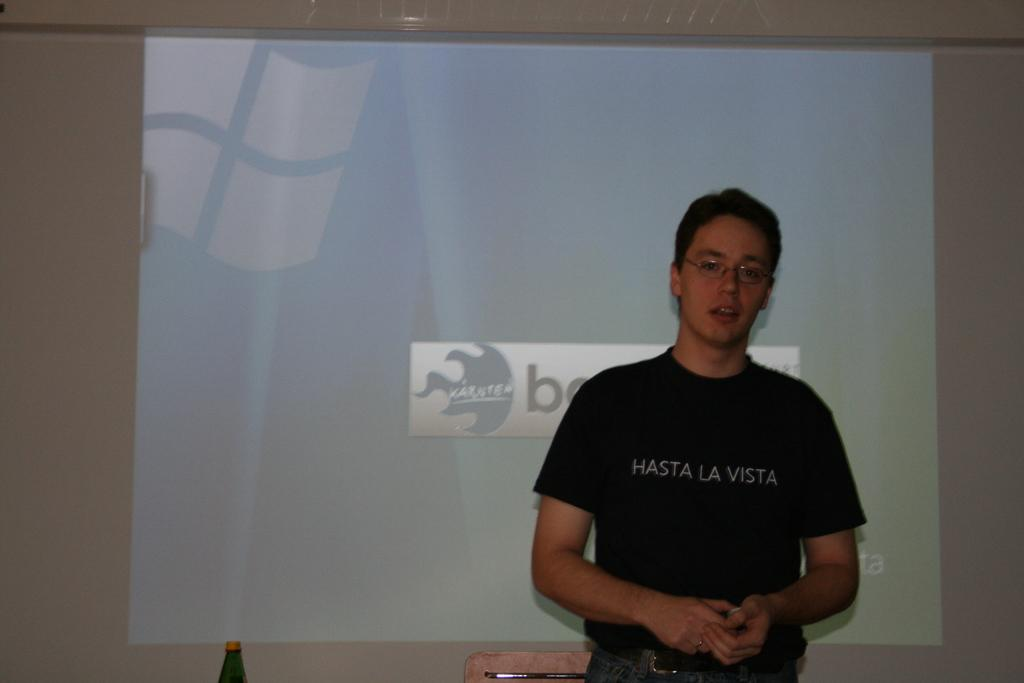What is the main subject of the image? There is a man standing in the image. Can you describe the man's appearance? The man is wearing spectacles. What can be seen in the background of the image? There is a projector wall in the background. What furniture is present in the image? There is a table in the image. What object is on the table? There is a bottle on the table. What type of disease is the man suffering from in the image? There is no indication in the image that the man is suffering from any disease. Can you describe the boot that the man is wearing in the image? There is no boot visible in the image; the man is wearing spectacles, but no footwear is mentioned or shown. 